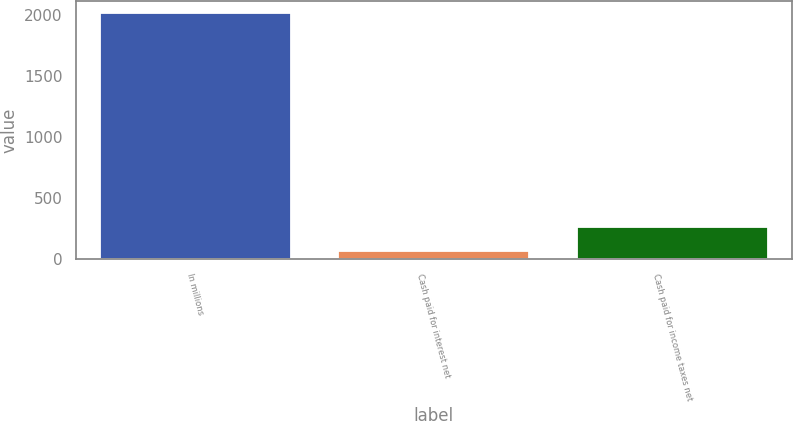Convert chart to OTSL. <chart><loc_0><loc_0><loc_500><loc_500><bar_chart><fcel>In millions<fcel>Cash paid for interest net<fcel>Cash paid for income taxes net<nl><fcel>2014<fcel>67.5<fcel>262.15<nl></chart> 